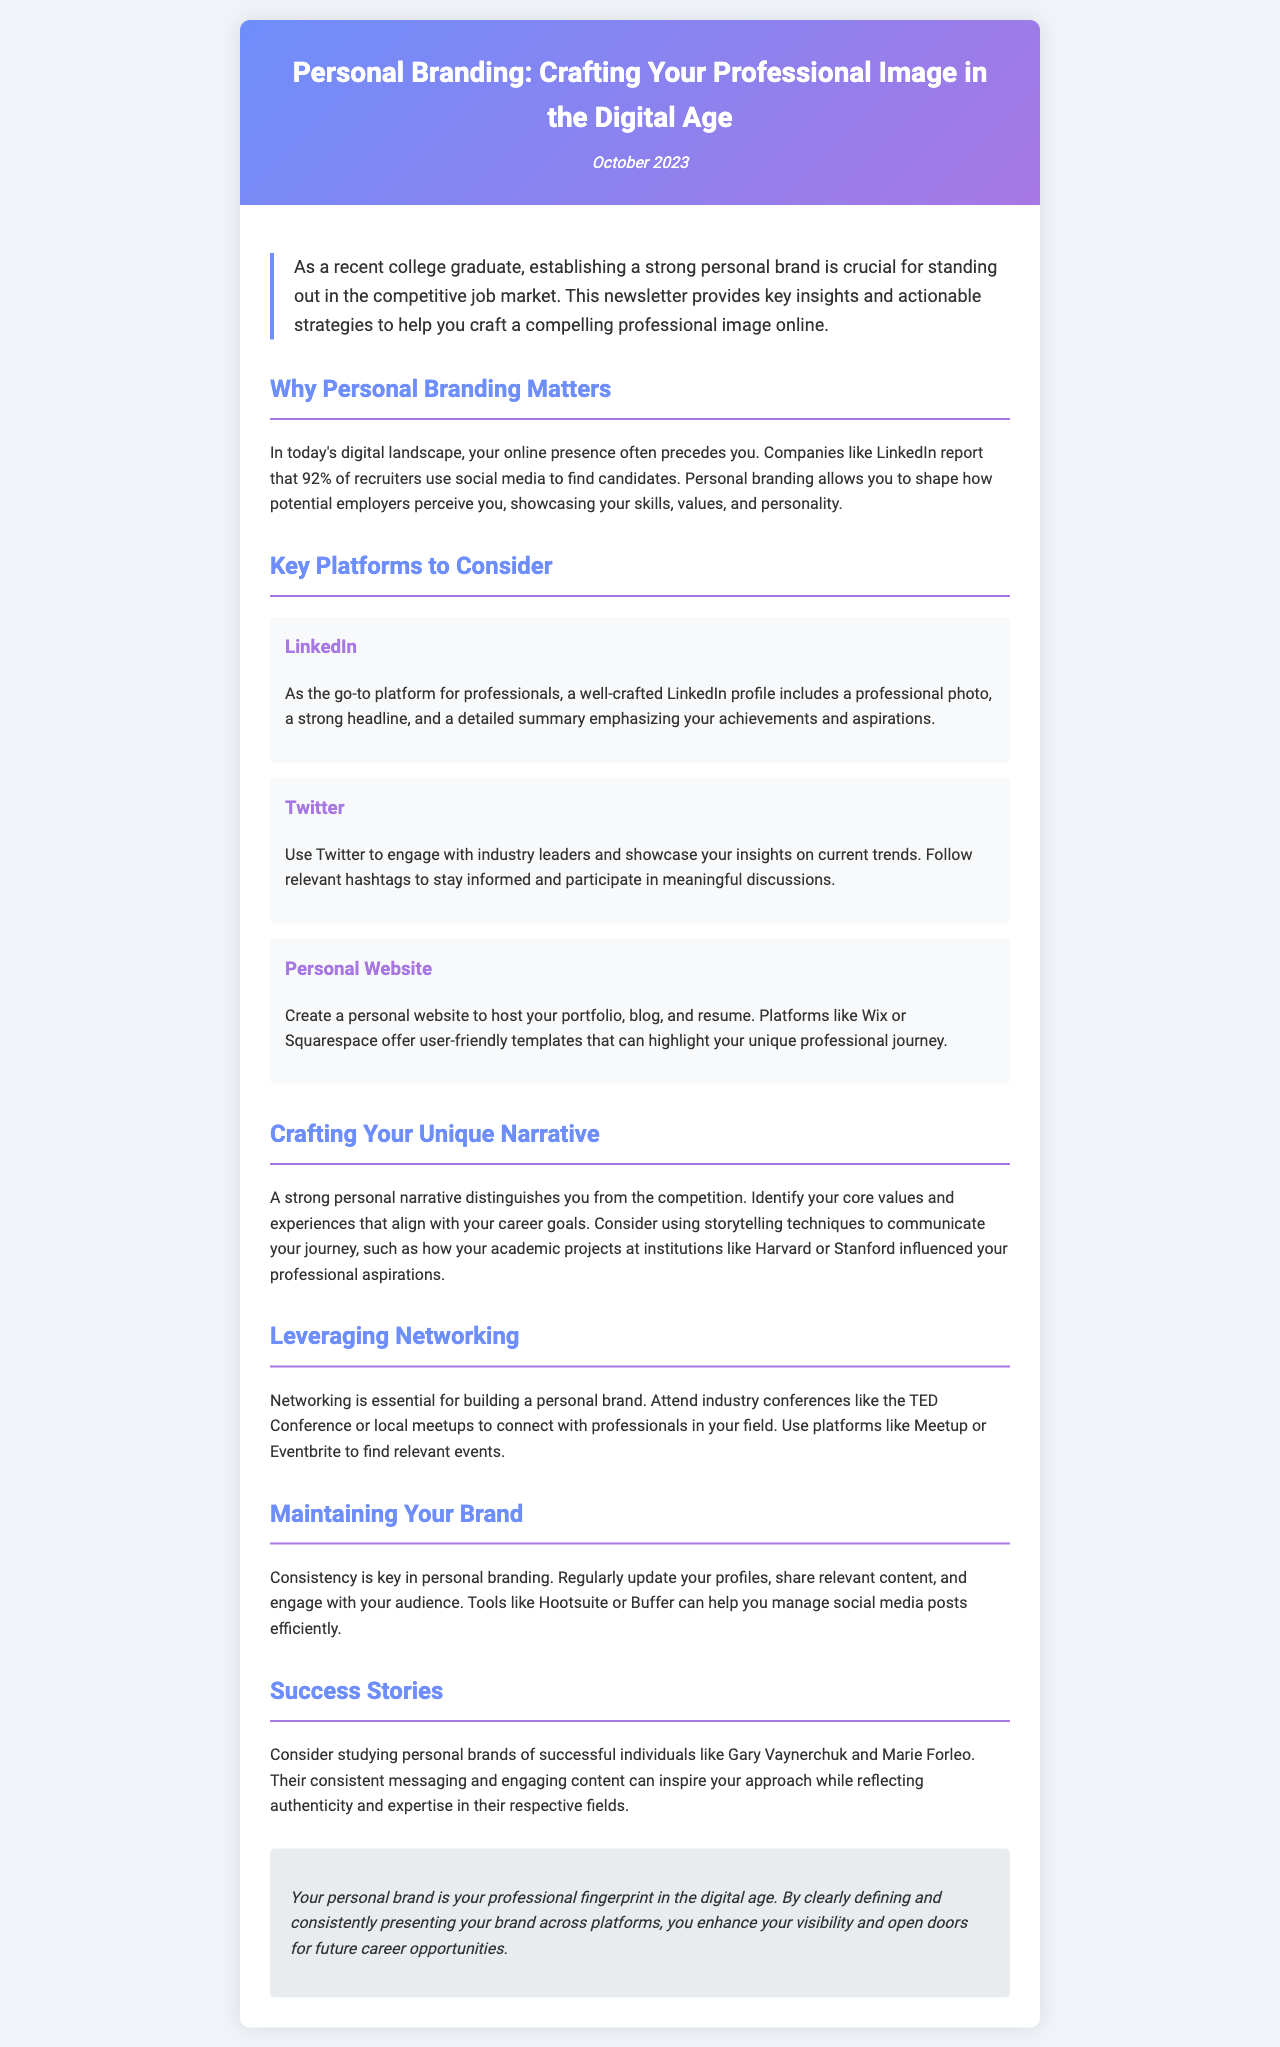What is the title of the newsletter? The title of the newsletter is prominently displayed at the top of the document.
Answer: Personal Branding: Crafting Your Professional Image in the Digital Age When was the newsletter published? The publication date is noted in the header section of the document.
Answer: October 2023 What percentage of recruiters use social media to find candidates? This statistic is mentioned in relation to personal branding and its importance.
Answer: 92% Name one key platform for personal branding mentioned in the newsletter. The document lists several platforms for branding, so identifying one suffices.
Answer: LinkedIn What is one recommended tool for managing social media posts? The newsletter suggests tools to help maintain your brand, including this type.
Answer: Hootsuite Why is consistency important in personal branding? The newsletter emphasizes the significance of maintaining a regular presence across platforms for visibility.
Answer: Consistency is key Which two successful individuals are mentioned as examples of personal branding? The document provides examples of successful personal brands for inspiration.
Answer: Gary Vaynerchuk and Marie Forleo What type of content should be shared to maintain your brand? This relates to the type of engagement suggested in the newsletter for a consistent presence.
Answer: Relevant content What is the main purpose of crafting a personal narrative? The document explains the importance of personal narratives in distinguishing individuals in their career pursuits.
Answer: To distinguish you from the competition 